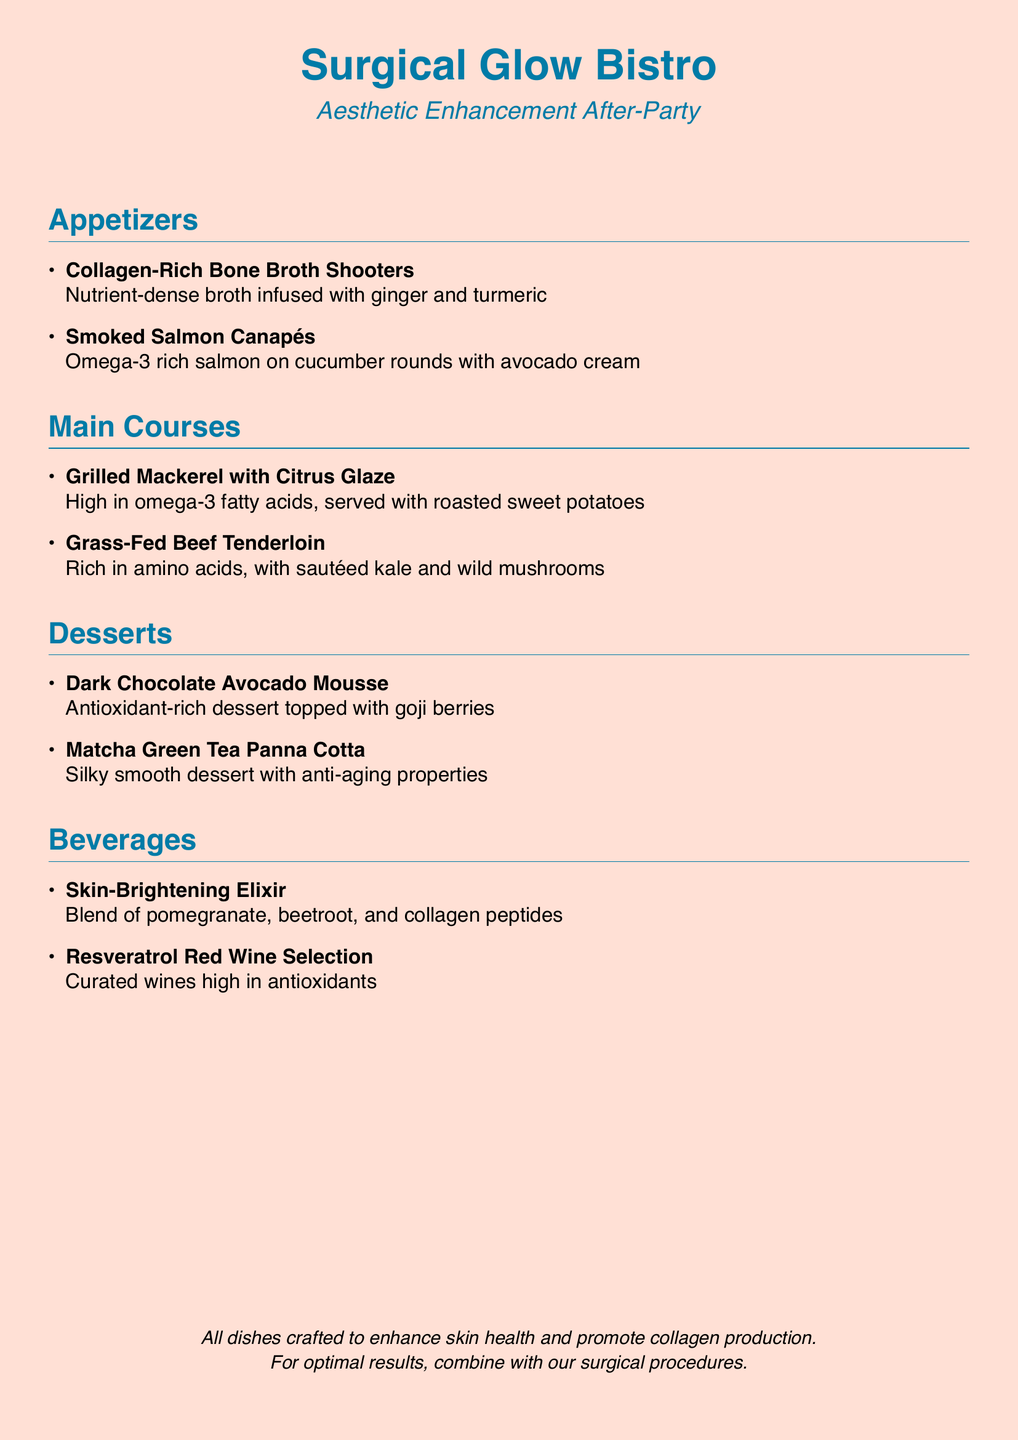How many appetizers are listed? The document lists two appetizers in the appetizers section.
Answer: 2 What is the main ingredient in the Dark Chocolate Avocado Mousse? The main ingredient mentioned in the dessert is dark chocolate and avocado.
Answer: Dark Chocolate Avocado What is the main health benefit associated with Smoked Salmon Canapés? The document indicates that they are rich in omega-3 fatty acids, promoting skin health.
Answer: Omega-3 What type of wine is included in the beverage section? The document specifies that it is a resveratrol red wine selection.
Answer: Resveratrol Red Wine Which appetizer is infused with ginger and turmeric? The document states that the Collagen-Rich Bone Broth Shooters are infused with ginger and turmeric.
Answer: Collagen-Rich Bone Broth Shooters How many main courses are featured on the menu? There are two main courses mentioned in the main courses section.
Answer: 2 What dessert is noted for its anti-aging properties? The matcha green tea panna cotta is highlighted for its anti-aging properties.
Answer: Matcha Green Tea Panna Cotta What is the theme of the menu described in the document? The theme of the menu is aesthetic enhancement with a focus on skin health and collagen production.
Answer: Aesthetic Enhancement 